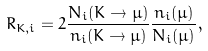Convert formula to latex. <formula><loc_0><loc_0><loc_500><loc_500>R _ { K , i } = 2 \frac { N _ { i } ( K \to \mu ) } { n _ { i } ( K \to \mu ) } \frac { n _ { i } ( \mu ) } { N _ { i } ( \mu ) } ,</formula> 